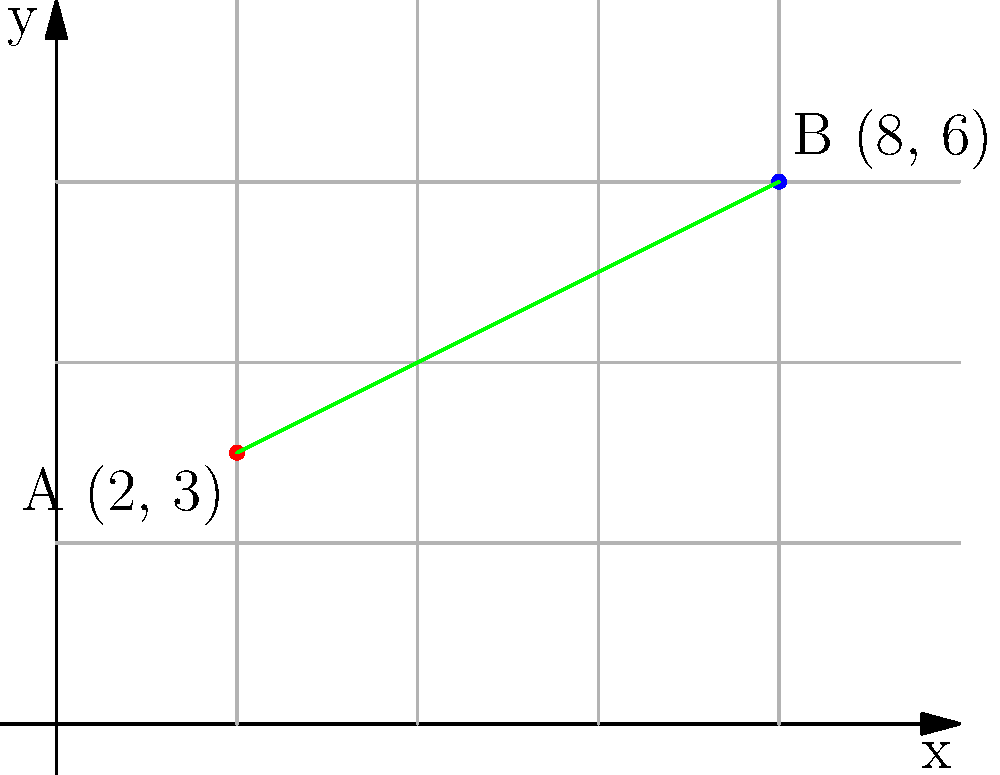At a literary festival, two author signing booths are set up at different locations on the festival grounds. Booth A is located at coordinates (2, 3), and Booth B is at coordinates (8, 6). As the event organizer, you need to calculate the straight-line distance between these two booths to ensure proper spacing. Using the distance formula, determine the distance between Booth A and Booth B. Round your answer to two decimal places. To solve this problem, we'll use the distance formula derived from the Pythagorean theorem:

$$ d = \sqrt{(x_2 - x_1)^2 + (y_2 - y_1)^2} $$

Where $(x_1, y_1)$ are the coordinates of the first point and $(x_2, y_2)$ are the coordinates of the second point.

Given:
- Booth A: $(x_1, y_1) = (2, 3)$
- Booth B: $(x_2, y_2) = (8, 6)$

Let's plug these values into the formula:

$$ d = \sqrt{(8 - 2)^2 + (6 - 3)^2} $$

Now, let's solve step by step:

1. Calculate the differences:
   $$ d = \sqrt{(6)^2 + (3)^2} $$

2. Square the differences:
   $$ d = \sqrt{36 + 9} $$

3. Add the squared differences:
   $$ d = \sqrt{45} $$

4. Calculate the square root:
   $$ d \approx 6.7082 $$

5. Round to two decimal places:
   $$ d \approx 6.71 $$

Therefore, the distance between Booth A and Booth B is approximately 6.71 units (assuming the grid represents some standard unit of measurement, like meters).
Answer: 6.71 units 